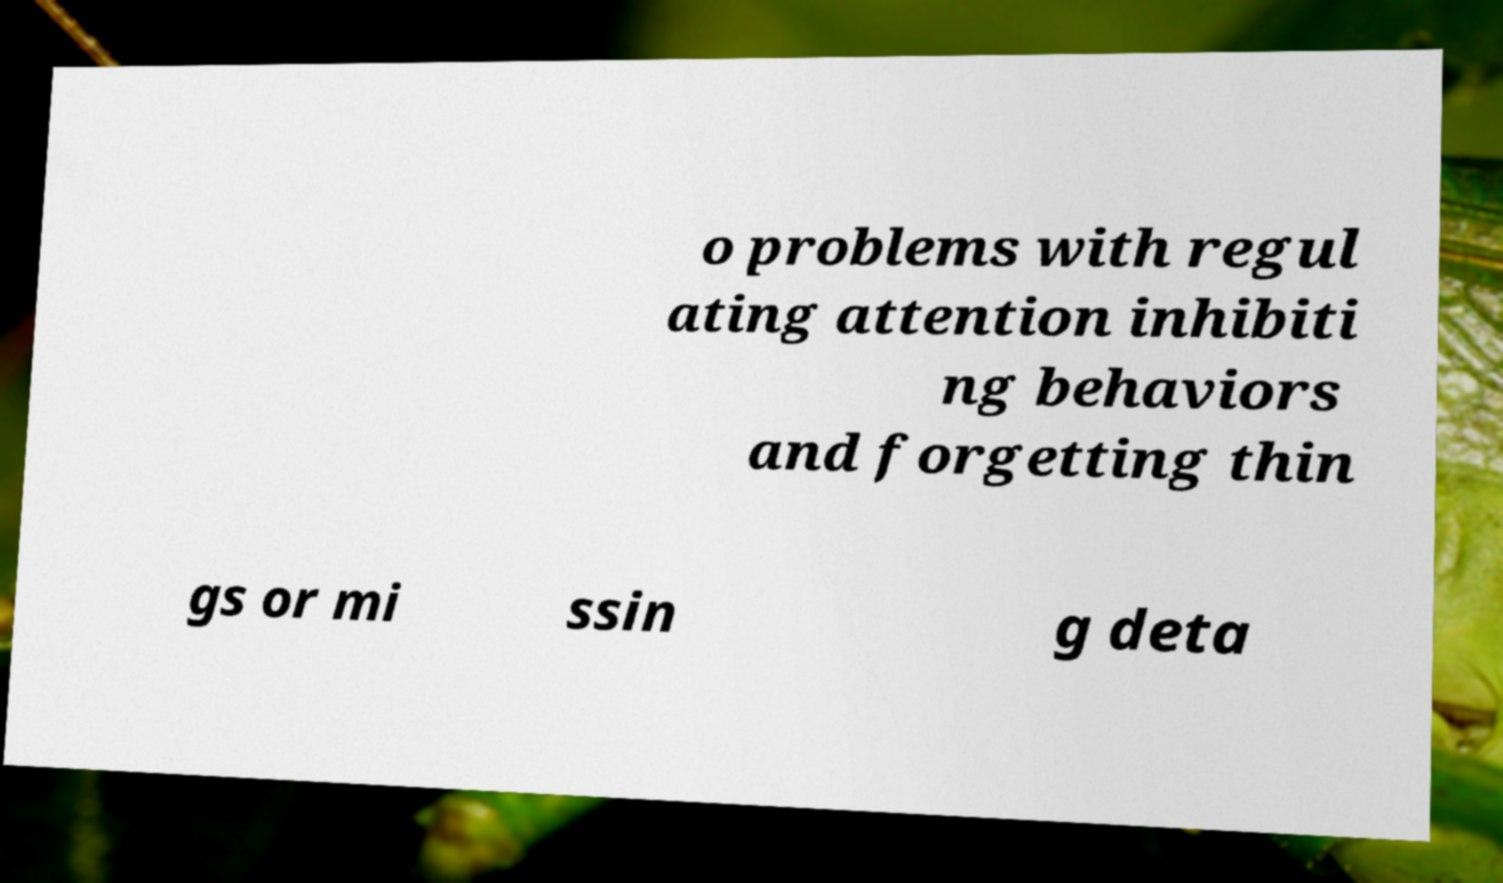There's text embedded in this image that I need extracted. Can you transcribe it verbatim? o problems with regul ating attention inhibiti ng behaviors and forgetting thin gs or mi ssin g deta 